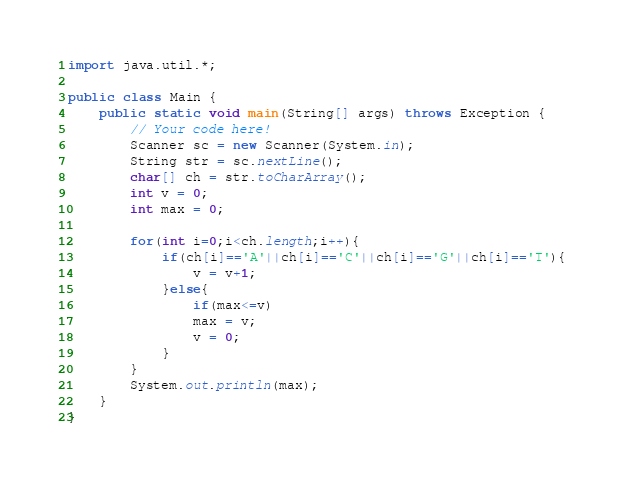Convert code to text. <code><loc_0><loc_0><loc_500><loc_500><_Java_>import java.util.*;

public class Main {
    public static void main(String[] args) throws Exception {
        // Your code here!
        Scanner sc = new Scanner(System.in);
        String str = sc.nextLine();
        char[] ch = str.toCharArray();
        int v = 0;
        int max = 0;
        
        for(int i=0;i<ch.length;i++){
            if(ch[i]=='A'||ch[i]=='C'||ch[i]=='G'||ch[i]=='T'){
                v = v+1;
            }else{
                if(max<=v)
                max = v;
                v = 0;
            }
        }
        System.out.println(max);
    }
}
</code> 